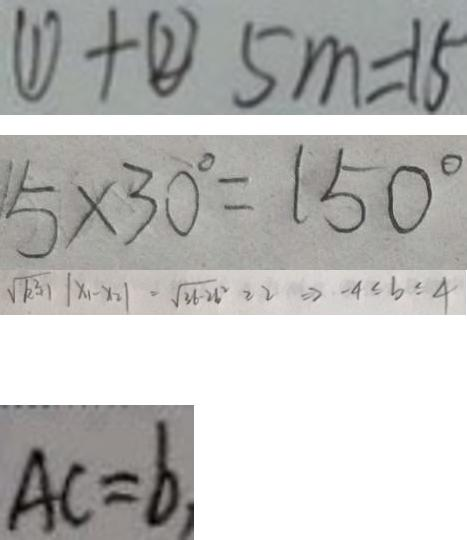Convert formula to latex. <formula><loc_0><loc_0><loc_500><loc_500>\textcircled { 1 } + \textcircled { 2 } 5 m = 1 5 
 5 \times 3 0 ^ { \circ } = 1 5 0 ^ { \circ } 
 \sqrt { k ^ { 2 } + 1 } \vert x _ { 1 } - x _ { 2 } \vert = \sqrt { 3 b - 2 b ^ { 2 } } \geq 2 \Rightarrow - 4 \leq b \leq 4 
 A C = b ,</formula> 